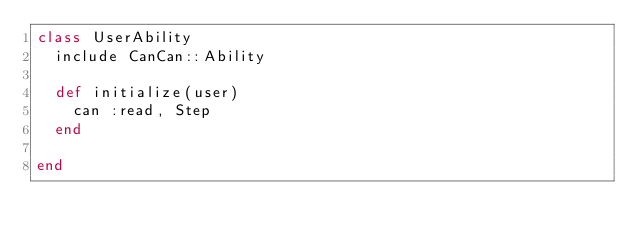<code> <loc_0><loc_0><loc_500><loc_500><_Ruby_>class UserAbility
  include CanCan::Ability

  def initialize(user)
    can :read, Step
  end

end
</code> 